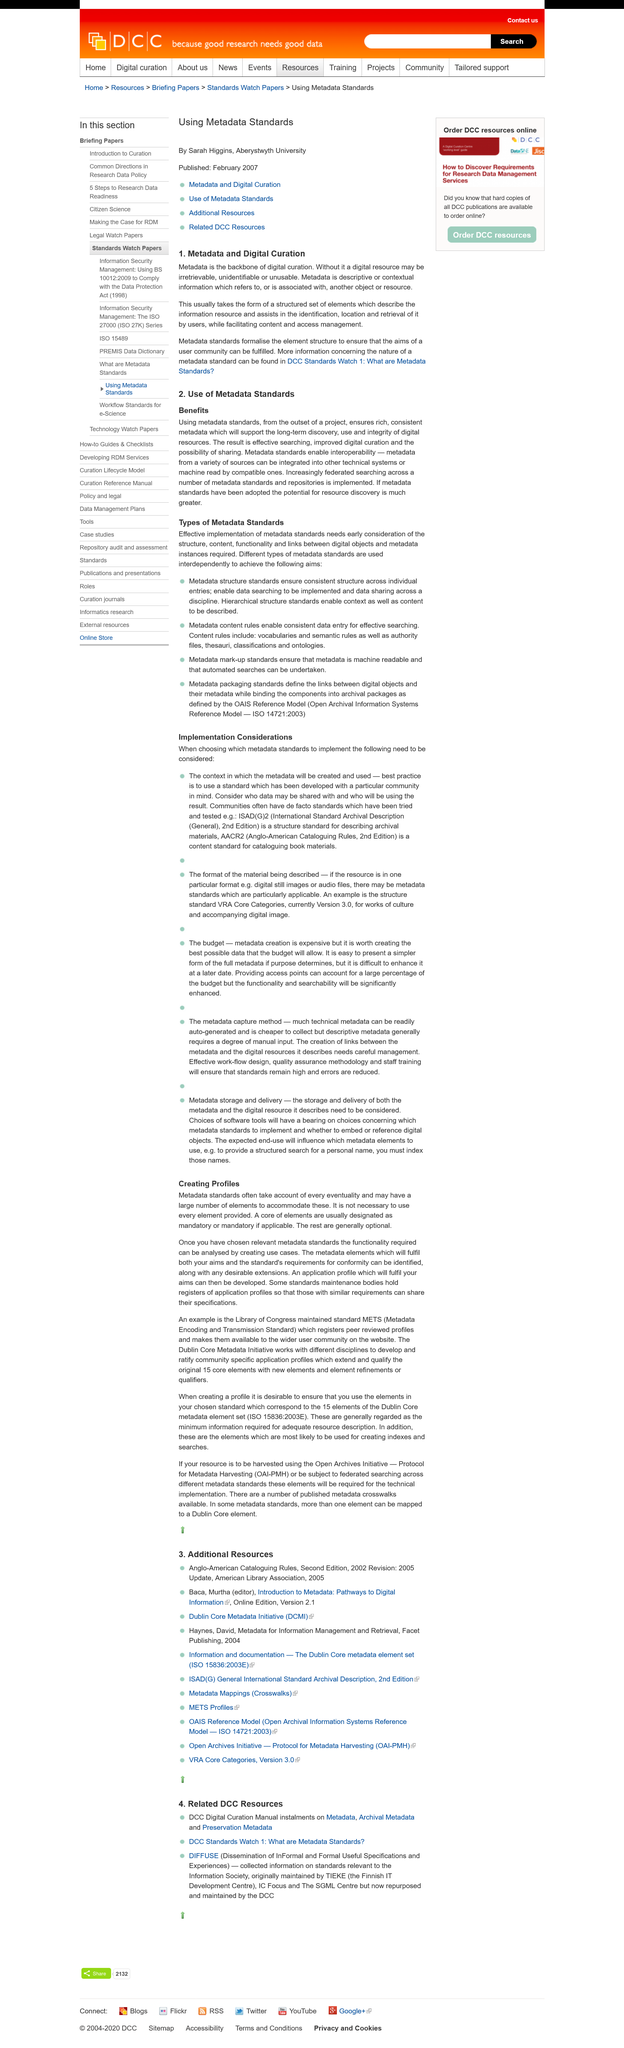Mention a couple of crucial points in this snapshot. Without metadata, a digital resource may become irretrievable, unidentifiable, and unusable. Metadata is the foundation and essential element of digital curation. Metadata standards formalize the element structure in order to fulfill the aims of a user community. 